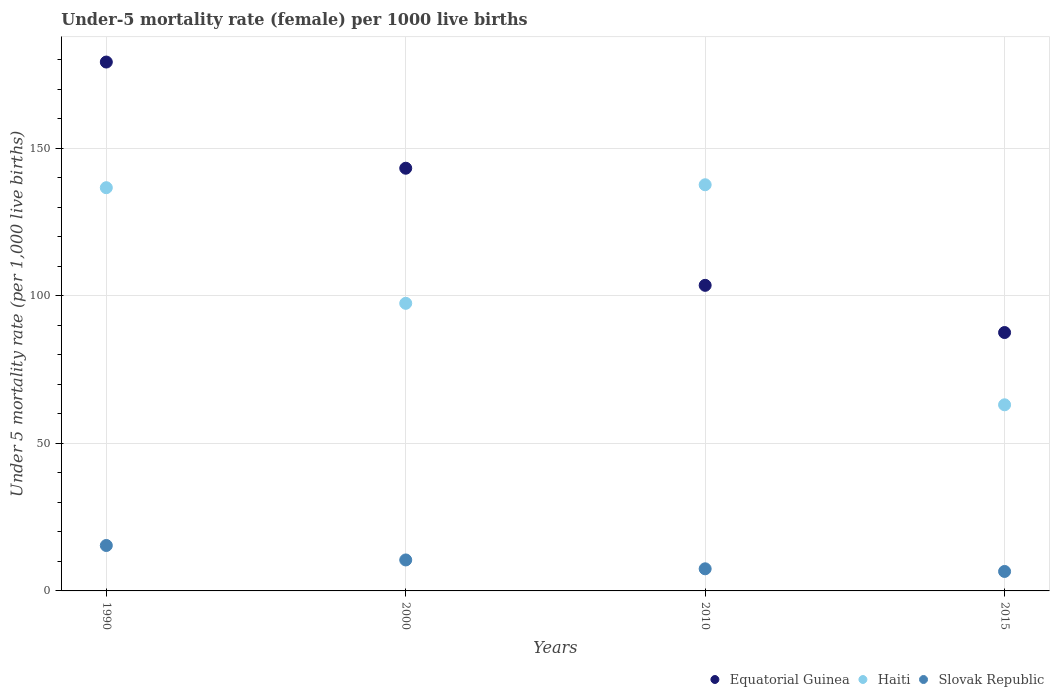Is the number of dotlines equal to the number of legend labels?
Your answer should be very brief. Yes. What is the under-five mortality rate in Haiti in 2015?
Offer a terse response. 63.1. Across all years, what is the maximum under-five mortality rate in Equatorial Guinea?
Ensure brevity in your answer.  179.3. Across all years, what is the minimum under-five mortality rate in Equatorial Guinea?
Provide a short and direct response. 87.6. In which year was the under-five mortality rate in Haiti minimum?
Make the answer very short. 2015. What is the total under-five mortality rate in Equatorial Guinea in the graph?
Provide a succinct answer. 513.8. What is the difference between the under-five mortality rate in Slovak Republic in 1990 and that in 2000?
Provide a short and direct response. 4.9. What is the difference between the under-five mortality rate in Slovak Republic in 2015 and the under-five mortality rate in Equatorial Guinea in 2010?
Keep it short and to the point. -97. In the year 2010, what is the difference between the under-five mortality rate in Equatorial Guinea and under-five mortality rate in Slovak Republic?
Your response must be concise. 96.1. In how many years, is the under-five mortality rate in Slovak Republic greater than 20?
Make the answer very short. 0. What is the difference between the highest and the lowest under-five mortality rate in Equatorial Guinea?
Make the answer very short. 91.7. In how many years, is the under-five mortality rate in Haiti greater than the average under-five mortality rate in Haiti taken over all years?
Offer a very short reply. 2. Is the sum of the under-five mortality rate in Haiti in 2000 and 2010 greater than the maximum under-five mortality rate in Slovak Republic across all years?
Ensure brevity in your answer.  Yes. Is it the case that in every year, the sum of the under-five mortality rate in Equatorial Guinea and under-five mortality rate in Slovak Republic  is greater than the under-five mortality rate in Haiti?
Give a very brief answer. No. Is the under-five mortality rate in Slovak Republic strictly less than the under-five mortality rate in Haiti over the years?
Your response must be concise. Yes. How many dotlines are there?
Your response must be concise. 3. What is the difference between two consecutive major ticks on the Y-axis?
Your response must be concise. 50. Does the graph contain grids?
Your answer should be compact. Yes. Where does the legend appear in the graph?
Keep it short and to the point. Bottom right. What is the title of the graph?
Your answer should be compact. Under-5 mortality rate (female) per 1000 live births. What is the label or title of the X-axis?
Provide a succinct answer. Years. What is the label or title of the Y-axis?
Give a very brief answer. Under 5 mortality rate (per 1,0 live births). What is the Under 5 mortality rate (per 1,000 live births) in Equatorial Guinea in 1990?
Keep it short and to the point. 179.3. What is the Under 5 mortality rate (per 1,000 live births) of Haiti in 1990?
Offer a very short reply. 136.7. What is the Under 5 mortality rate (per 1,000 live births) in Equatorial Guinea in 2000?
Your response must be concise. 143.3. What is the Under 5 mortality rate (per 1,000 live births) of Haiti in 2000?
Provide a short and direct response. 97.5. What is the Under 5 mortality rate (per 1,000 live births) in Equatorial Guinea in 2010?
Ensure brevity in your answer.  103.6. What is the Under 5 mortality rate (per 1,000 live births) in Haiti in 2010?
Offer a terse response. 137.7. What is the Under 5 mortality rate (per 1,000 live births) of Slovak Republic in 2010?
Make the answer very short. 7.5. What is the Under 5 mortality rate (per 1,000 live births) in Equatorial Guinea in 2015?
Give a very brief answer. 87.6. What is the Under 5 mortality rate (per 1,000 live births) of Haiti in 2015?
Provide a short and direct response. 63.1. What is the Under 5 mortality rate (per 1,000 live births) in Slovak Republic in 2015?
Give a very brief answer. 6.6. Across all years, what is the maximum Under 5 mortality rate (per 1,000 live births) of Equatorial Guinea?
Provide a succinct answer. 179.3. Across all years, what is the maximum Under 5 mortality rate (per 1,000 live births) in Haiti?
Your answer should be compact. 137.7. Across all years, what is the maximum Under 5 mortality rate (per 1,000 live births) in Slovak Republic?
Offer a terse response. 15.4. Across all years, what is the minimum Under 5 mortality rate (per 1,000 live births) of Equatorial Guinea?
Provide a short and direct response. 87.6. Across all years, what is the minimum Under 5 mortality rate (per 1,000 live births) of Haiti?
Keep it short and to the point. 63.1. What is the total Under 5 mortality rate (per 1,000 live births) of Equatorial Guinea in the graph?
Provide a succinct answer. 513.8. What is the total Under 5 mortality rate (per 1,000 live births) of Haiti in the graph?
Give a very brief answer. 435. What is the difference between the Under 5 mortality rate (per 1,000 live births) of Equatorial Guinea in 1990 and that in 2000?
Provide a short and direct response. 36. What is the difference between the Under 5 mortality rate (per 1,000 live births) of Haiti in 1990 and that in 2000?
Provide a succinct answer. 39.2. What is the difference between the Under 5 mortality rate (per 1,000 live births) in Equatorial Guinea in 1990 and that in 2010?
Offer a terse response. 75.7. What is the difference between the Under 5 mortality rate (per 1,000 live births) of Haiti in 1990 and that in 2010?
Make the answer very short. -1. What is the difference between the Under 5 mortality rate (per 1,000 live births) of Slovak Republic in 1990 and that in 2010?
Offer a very short reply. 7.9. What is the difference between the Under 5 mortality rate (per 1,000 live births) in Equatorial Guinea in 1990 and that in 2015?
Your response must be concise. 91.7. What is the difference between the Under 5 mortality rate (per 1,000 live births) of Haiti in 1990 and that in 2015?
Keep it short and to the point. 73.6. What is the difference between the Under 5 mortality rate (per 1,000 live births) of Slovak Republic in 1990 and that in 2015?
Your answer should be very brief. 8.8. What is the difference between the Under 5 mortality rate (per 1,000 live births) of Equatorial Guinea in 2000 and that in 2010?
Ensure brevity in your answer.  39.7. What is the difference between the Under 5 mortality rate (per 1,000 live births) in Haiti in 2000 and that in 2010?
Provide a short and direct response. -40.2. What is the difference between the Under 5 mortality rate (per 1,000 live births) of Slovak Republic in 2000 and that in 2010?
Offer a very short reply. 3. What is the difference between the Under 5 mortality rate (per 1,000 live births) in Equatorial Guinea in 2000 and that in 2015?
Give a very brief answer. 55.7. What is the difference between the Under 5 mortality rate (per 1,000 live births) in Haiti in 2000 and that in 2015?
Offer a very short reply. 34.4. What is the difference between the Under 5 mortality rate (per 1,000 live births) of Slovak Republic in 2000 and that in 2015?
Offer a terse response. 3.9. What is the difference between the Under 5 mortality rate (per 1,000 live births) of Haiti in 2010 and that in 2015?
Give a very brief answer. 74.6. What is the difference between the Under 5 mortality rate (per 1,000 live births) in Slovak Republic in 2010 and that in 2015?
Your response must be concise. 0.9. What is the difference between the Under 5 mortality rate (per 1,000 live births) in Equatorial Guinea in 1990 and the Under 5 mortality rate (per 1,000 live births) in Haiti in 2000?
Keep it short and to the point. 81.8. What is the difference between the Under 5 mortality rate (per 1,000 live births) of Equatorial Guinea in 1990 and the Under 5 mortality rate (per 1,000 live births) of Slovak Republic in 2000?
Your answer should be compact. 168.8. What is the difference between the Under 5 mortality rate (per 1,000 live births) of Haiti in 1990 and the Under 5 mortality rate (per 1,000 live births) of Slovak Republic in 2000?
Offer a terse response. 126.2. What is the difference between the Under 5 mortality rate (per 1,000 live births) of Equatorial Guinea in 1990 and the Under 5 mortality rate (per 1,000 live births) of Haiti in 2010?
Your answer should be compact. 41.6. What is the difference between the Under 5 mortality rate (per 1,000 live births) of Equatorial Guinea in 1990 and the Under 5 mortality rate (per 1,000 live births) of Slovak Republic in 2010?
Offer a very short reply. 171.8. What is the difference between the Under 5 mortality rate (per 1,000 live births) of Haiti in 1990 and the Under 5 mortality rate (per 1,000 live births) of Slovak Republic in 2010?
Make the answer very short. 129.2. What is the difference between the Under 5 mortality rate (per 1,000 live births) in Equatorial Guinea in 1990 and the Under 5 mortality rate (per 1,000 live births) in Haiti in 2015?
Offer a very short reply. 116.2. What is the difference between the Under 5 mortality rate (per 1,000 live births) in Equatorial Guinea in 1990 and the Under 5 mortality rate (per 1,000 live births) in Slovak Republic in 2015?
Your answer should be compact. 172.7. What is the difference between the Under 5 mortality rate (per 1,000 live births) of Haiti in 1990 and the Under 5 mortality rate (per 1,000 live births) of Slovak Republic in 2015?
Give a very brief answer. 130.1. What is the difference between the Under 5 mortality rate (per 1,000 live births) in Equatorial Guinea in 2000 and the Under 5 mortality rate (per 1,000 live births) in Haiti in 2010?
Provide a short and direct response. 5.6. What is the difference between the Under 5 mortality rate (per 1,000 live births) of Equatorial Guinea in 2000 and the Under 5 mortality rate (per 1,000 live births) of Slovak Republic in 2010?
Your answer should be very brief. 135.8. What is the difference between the Under 5 mortality rate (per 1,000 live births) of Haiti in 2000 and the Under 5 mortality rate (per 1,000 live births) of Slovak Republic in 2010?
Offer a very short reply. 90. What is the difference between the Under 5 mortality rate (per 1,000 live births) in Equatorial Guinea in 2000 and the Under 5 mortality rate (per 1,000 live births) in Haiti in 2015?
Offer a terse response. 80.2. What is the difference between the Under 5 mortality rate (per 1,000 live births) of Equatorial Guinea in 2000 and the Under 5 mortality rate (per 1,000 live births) of Slovak Republic in 2015?
Offer a terse response. 136.7. What is the difference between the Under 5 mortality rate (per 1,000 live births) of Haiti in 2000 and the Under 5 mortality rate (per 1,000 live births) of Slovak Republic in 2015?
Ensure brevity in your answer.  90.9. What is the difference between the Under 5 mortality rate (per 1,000 live births) in Equatorial Guinea in 2010 and the Under 5 mortality rate (per 1,000 live births) in Haiti in 2015?
Your answer should be very brief. 40.5. What is the difference between the Under 5 mortality rate (per 1,000 live births) in Equatorial Guinea in 2010 and the Under 5 mortality rate (per 1,000 live births) in Slovak Republic in 2015?
Your answer should be compact. 97. What is the difference between the Under 5 mortality rate (per 1,000 live births) of Haiti in 2010 and the Under 5 mortality rate (per 1,000 live births) of Slovak Republic in 2015?
Ensure brevity in your answer.  131.1. What is the average Under 5 mortality rate (per 1,000 live births) in Equatorial Guinea per year?
Your answer should be very brief. 128.45. What is the average Under 5 mortality rate (per 1,000 live births) of Haiti per year?
Your answer should be compact. 108.75. In the year 1990, what is the difference between the Under 5 mortality rate (per 1,000 live births) of Equatorial Guinea and Under 5 mortality rate (per 1,000 live births) of Haiti?
Make the answer very short. 42.6. In the year 1990, what is the difference between the Under 5 mortality rate (per 1,000 live births) in Equatorial Guinea and Under 5 mortality rate (per 1,000 live births) in Slovak Republic?
Your response must be concise. 163.9. In the year 1990, what is the difference between the Under 5 mortality rate (per 1,000 live births) in Haiti and Under 5 mortality rate (per 1,000 live births) in Slovak Republic?
Keep it short and to the point. 121.3. In the year 2000, what is the difference between the Under 5 mortality rate (per 1,000 live births) of Equatorial Guinea and Under 5 mortality rate (per 1,000 live births) of Haiti?
Offer a terse response. 45.8. In the year 2000, what is the difference between the Under 5 mortality rate (per 1,000 live births) of Equatorial Guinea and Under 5 mortality rate (per 1,000 live births) of Slovak Republic?
Offer a very short reply. 132.8. In the year 2010, what is the difference between the Under 5 mortality rate (per 1,000 live births) of Equatorial Guinea and Under 5 mortality rate (per 1,000 live births) of Haiti?
Your answer should be compact. -34.1. In the year 2010, what is the difference between the Under 5 mortality rate (per 1,000 live births) in Equatorial Guinea and Under 5 mortality rate (per 1,000 live births) in Slovak Republic?
Offer a very short reply. 96.1. In the year 2010, what is the difference between the Under 5 mortality rate (per 1,000 live births) of Haiti and Under 5 mortality rate (per 1,000 live births) of Slovak Republic?
Offer a very short reply. 130.2. In the year 2015, what is the difference between the Under 5 mortality rate (per 1,000 live births) of Haiti and Under 5 mortality rate (per 1,000 live births) of Slovak Republic?
Provide a succinct answer. 56.5. What is the ratio of the Under 5 mortality rate (per 1,000 live births) of Equatorial Guinea in 1990 to that in 2000?
Your answer should be compact. 1.25. What is the ratio of the Under 5 mortality rate (per 1,000 live births) of Haiti in 1990 to that in 2000?
Provide a short and direct response. 1.4. What is the ratio of the Under 5 mortality rate (per 1,000 live births) of Slovak Republic in 1990 to that in 2000?
Your response must be concise. 1.47. What is the ratio of the Under 5 mortality rate (per 1,000 live births) of Equatorial Guinea in 1990 to that in 2010?
Your answer should be very brief. 1.73. What is the ratio of the Under 5 mortality rate (per 1,000 live births) in Haiti in 1990 to that in 2010?
Your answer should be compact. 0.99. What is the ratio of the Under 5 mortality rate (per 1,000 live births) of Slovak Republic in 1990 to that in 2010?
Make the answer very short. 2.05. What is the ratio of the Under 5 mortality rate (per 1,000 live births) of Equatorial Guinea in 1990 to that in 2015?
Give a very brief answer. 2.05. What is the ratio of the Under 5 mortality rate (per 1,000 live births) of Haiti in 1990 to that in 2015?
Your response must be concise. 2.17. What is the ratio of the Under 5 mortality rate (per 1,000 live births) in Slovak Republic in 1990 to that in 2015?
Give a very brief answer. 2.33. What is the ratio of the Under 5 mortality rate (per 1,000 live births) in Equatorial Guinea in 2000 to that in 2010?
Your response must be concise. 1.38. What is the ratio of the Under 5 mortality rate (per 1,000 live births) in Haiti in 2000 to that in 2010?
Your answer should be very brief. 0.71. What is the ratio of the Under 5 mortality rate (per 1,000 live births) in Slovak Republic in 2000 to that in 2010?
Give a very brief answer. 1.4. What is the ratio of the Under 5 mortality rate (per 1,000 live births) in Equatorial Guinea in 2000 to that in 2015?
Give a very brief answer. 1.64. What is the ratio of the Under 5 mortality rate (per 1,000 live births) in Haiti in 2000 to that in 2015?
Your answer should be very brief. 1.55. What is the ratio of the Under 5 mortality rate (per 1,000 live births) of Slovak Republic in 2000 to that in 2015?
Your response must be concise. 1.59. What is the ratio of the Under 5 mortality rate (per 1,000 live births) of Equatorial Guinea in 2010 to that in 2015?
Offer a very short reply. 1.18. What is the ratio of the Under 5 mortality rate (per 1,000 live births) of Haiti in 2010 to that in 2015?
Make the answer very short. 2.18. What is the ratio of the Under 5 mortality rate (per 1,000 live births) of Slovak Republic in 2010 to that in 2015?
Provide a short and direct response. 1.14. What is the difference between the highest and the second highest Under 5 mortality rate (per 1,000 live births) in Equatorial Guinea?
Provide a succinct answer. 36. What is the difference between the highest and the lowest Under 5 mortality rate (per 1,000 live births) in Equatorial Guinea?
Give a very brief answer. 91.7. What is the difference between the highest and the lowest Under 5 mortality rate (per 1,000 live births) in Haiti?
Provide a short and direct response. 74.6. What is the difference between the highest and the lowest Under 5 mortality rate (per 1,000 live births) of Slovak Republic?
Your answer should be compact. 8.8. 